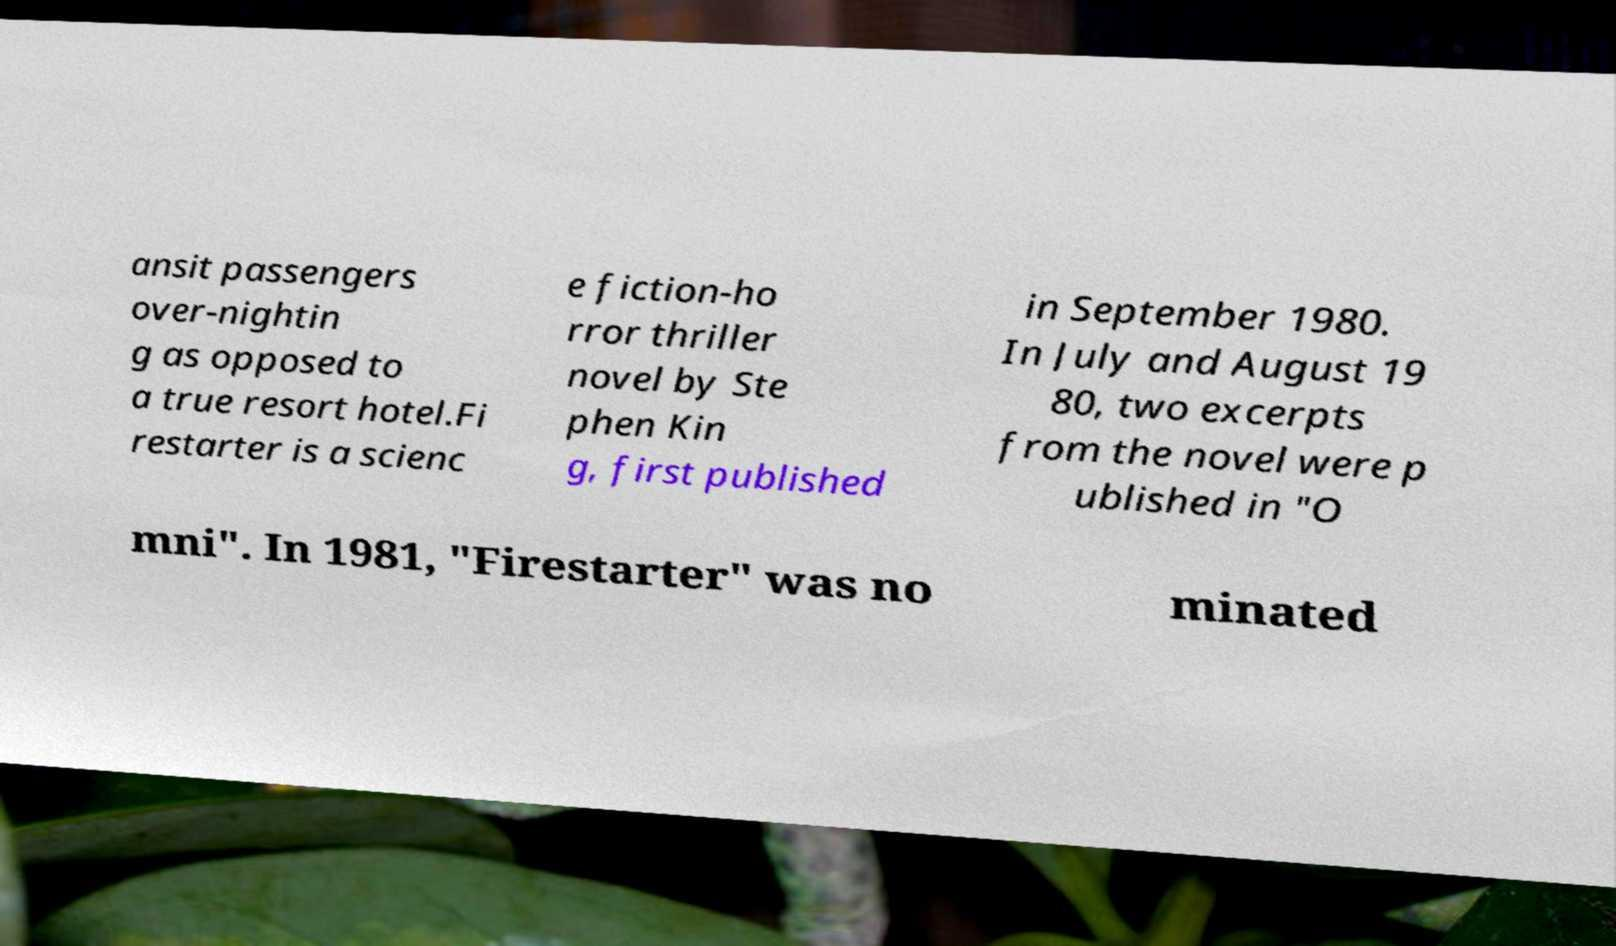Could you extract and type out the text from this image? ansit passengers over-nightin g as opposed to a true resort hotel.Fi restarter is a scienc e fiction-ho rror thriller novel by Ste phen Kin g, first published in September 1980. In July and August 19 80, two excerpts from the novel were p ublished in "O mni". In 1981, "Firestarter" was no minated 